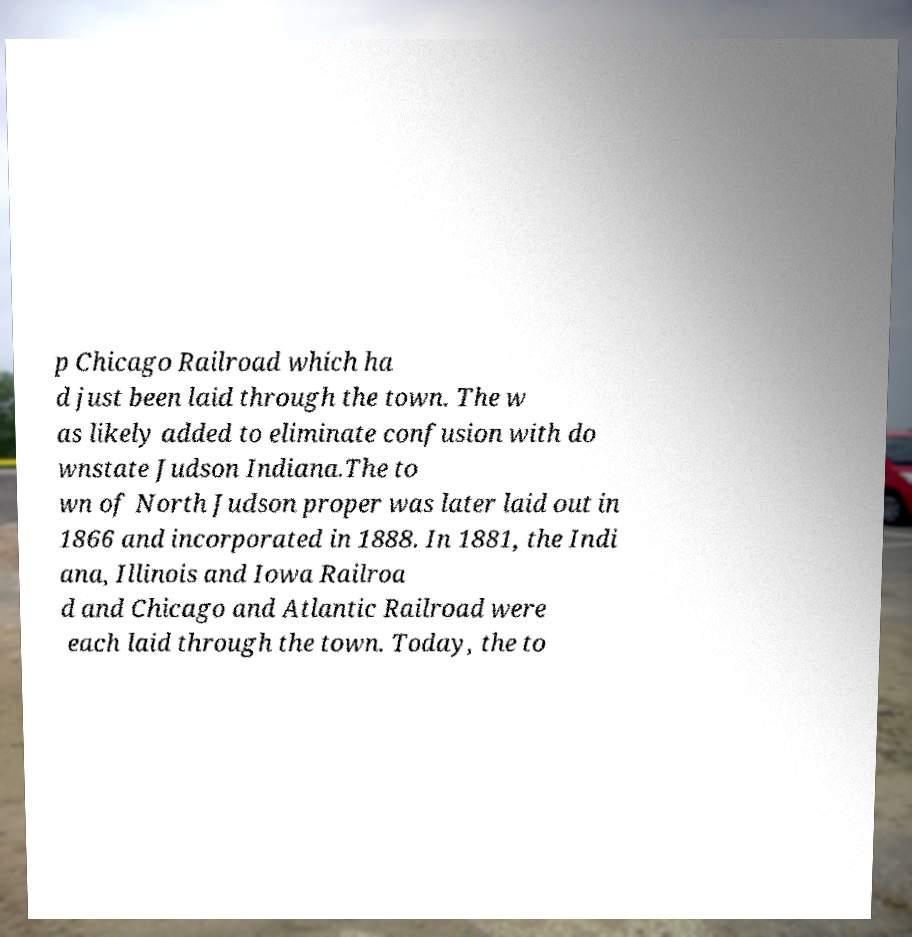There's text embedded in this image that I need extracted. Can you transcribe it verbatim? p Chicago Railroad which ha d just been laid through the town. The w as likely added to eliminate confusion with do wnstate Judson Indiana.The to wn of North Judson proper was later laid out in 1866 and incorporated in 1888. In 1881, the Indi ana, Illinois and Iowa Railroa d and Chicago and Atlantic Railroad were each laid through the town. Today, the to 